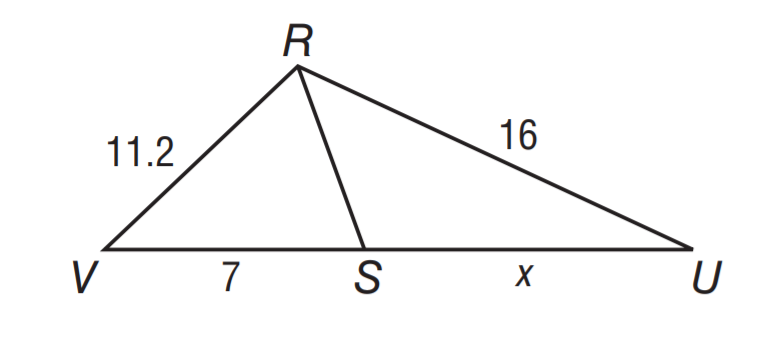Question: R S bisects \angle V R U. Solve for x.
Choices:
A. 5.6
B. 7
C. 8
D. 10
Answer with the letter. Answer: D 